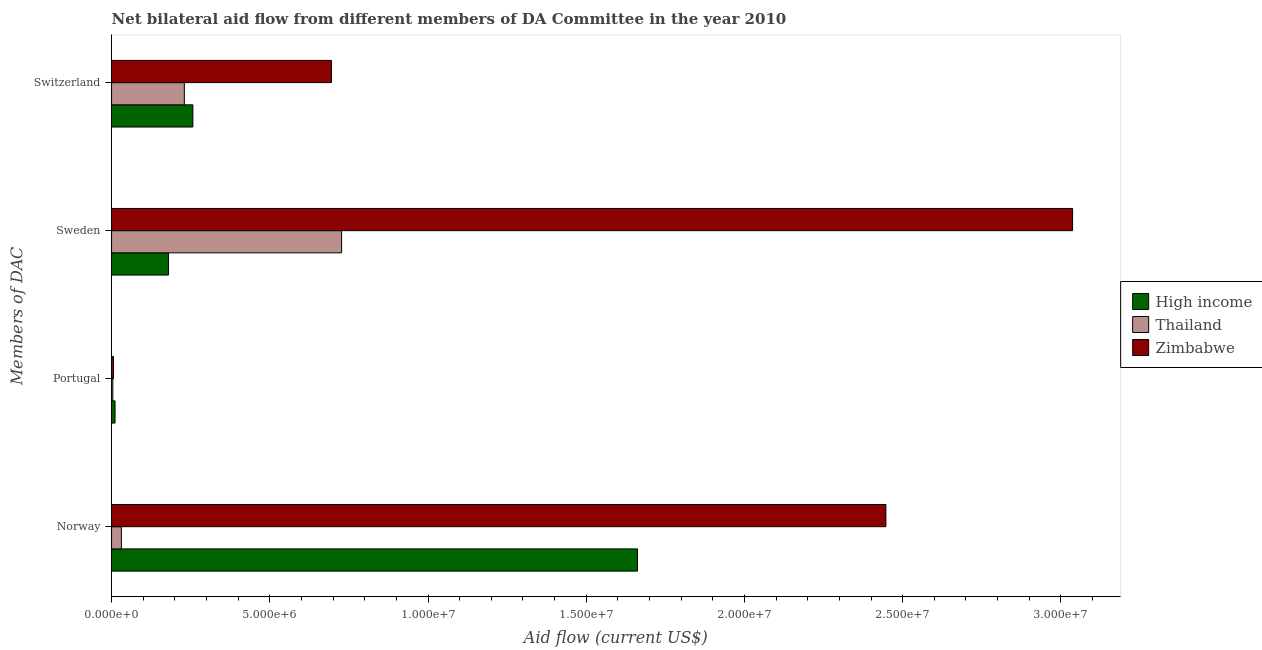How many groups of bars are there?
Ensure brevity in your answer.  4. Are the number of bars per tick equal to the number of legend labels?
Provide a short and direct response. Yes. How many bars are there on the 1st tick from the top?
Provide a short and direct response. 3. What is the label of the 3rd group of bars from the top?
Your answer should be very brief. Portugal. What is the amount of aid given by portugal in Zimbabwe?
Ensure brevity in your answer.  6.00e+04. Across all countries, what is the maximum amount of aid given by sweden?
Keep it short and to the point. 3.04e+07. Across all countries, what is the minimum amount of aid given by portugal?
Keep it short and to the point. 4.00e+04. In which country was the amount of aid given by norway minimum?
Your response must be concise. Thailand. What is the total amount of aid given by switzerland in the graph?
Your response must be concise. 1.18e+07. What is the difference between the amount of aid given by norway in Thailand and that in High income?
Offer a very short reply. -1.63e+07. What is the difference between the amount of aid given by sweden in High income and the amount of aid given by norway in Zimbabwe?
Keep it short and to the point. -2.27e+07. What is the average amount of aid given by portugal per country?
Provide a short and direct response. 7.00e+04. What is the difference between the amount of aid given by portugal and amount of aid given by sweden in High income?
Provide a succinct answer. -1.69e+06. What is the ratio of the amount of aid given by portugal in Zimbabwe to that in High income?
Your answer should be very brief. 0.55. What is the difference between the highest and the second highest amount of aid given by portugal?
Offer a terse response. 5.00e+04. What is the difference between the highest and the lowest amount of aid given by switzerland?
Offer a very short reply. 4.65e+06. Is the sum of the amount of aid given by portugal in Thailand and Zimbabwe greater than the maximum amount of aid given by sweden across all countries?
Offer a very short reply. No. Is it the case that in every country, the sum of the amount of aid given by portugal and amount of aid given by switzerland is greater than the sum of amount of aid given by norway and amount of aid given by sweden?
Your answer should be compact. Yes. What does the 3rd bar from the bottom in Switzerland represents?
Offer a terse response. Zimbabwe. Are all the bars in the graph horizontal?
Your answer should be very brief. Yes. How many countries are there in the graph?
Your response must be concise. 3. Are the values on the major ticks of X-axis written in scientific E-notation?
Make the answer very short. Yes. Where does the legend appear in the graph?
Keep it short and to the point. Center right. What is the title of the graph?
Offer a terse response. Net bilateral aid flow from different members of DA Committee in the year 2010. What is the label or title of the Y-axis?
Your answer should be very brief. Members of DAC. What is the Aid flow (current US$) of High income in Norway?
Give a very brief answer. 1.66e+07. What is the Aid flow (current US$) in Zimbabwe in Norway?
Your answer should be very brief. 2.45e+07. What is the Aid flow (current US$) in High income in Portugal?
Provide a short and direct response. 1.10e+05. What is the Aid flow (current US$) of Thailand in Portugal?
Ensure brevity in your answer.  4.00e+04. What is the Aid flow (current US$) of High income in Sweden?
Give a very brief answer. 1.80e+06. What is the Aid flow (current US$) of Thailand in Sweden?
Give a very brief answer. 7.27e+06. What is the Aid flow (current US$) of Zimbabwe in Sweden?
Offer a terse response. 3.04e+07. What is the Aid flow (current US$) of High income in Switzerland?
Make the answer very short. 2.57e+06. What is the Aid flow (current US$) of Thailand in Switzerland?
Make the answer very short. 2.30e+06. What is the Aid flow (current US$) in Zimbabwe in Switzerland?
Make the answer very short. 6.95e+06. Across all Members of DAC, what is the maximum Aid flow (current US$) of High income?
Your response must be concise. 1.66e+07. Across all Members of DAC, what is the maximum Aid flow (current US$) in Thailand?
Ensure brevity in your answer.  7.27e+06. Across all Members of DAC, what is the maximum Aid flow (current US$) of Zimbabwe?
Provide a succinct answer. 3.04e+07. What is the total Aid flow (current US$) of High income in the graph?
Offer a terse response. 2.11e+07. What is the total Aid flow (current US$) in Thailand in the graph?
Provide a short and direct response. 9.92e+06. What is the total Aid flow (current US$) of Zimbabwe in the graph?
Provide a short and direct response. 6.18e+07. What is the difference between the Aid flow (current US$) of High income in Norway and that in Portugal?
Provide a succinct answer. 1.65e+07. What is the difference between the Aid flow (current US$) in Thailand in Norway and that in Portugal?
Your response must be concise. 2.70e+05. What is the difference between the Aid flow (current US$) in Zimbabwe in Norway and that in Portugal?
Provide a succinct answer. 2.44e+07. What is the difference between the Aid flow (current US$) in High income in Norway and that in Sweden?
Offer a very short reply. 1.48e+07. What is the difference between the Aid flow (current US$) of Thailand in Norway and that in Sweden?
Provide a succinct answer. -6.96e+06. What is the difference between the Aid flow (current US$) of Zimbabwe in Norway and that in Sweden?
Offer a very short reply. -5.90e+06. What is the difference between the Aid flow (current US$) of High income in Norway and that in Switzerland?
Ensure brevity in your answer.  1.40e+07. What is the difference between the Aid flow (current US$) of Thailand in Norway and that in Switzerland?
Your response must be concise. -1.99e+06. What is the difference between the Aid flow (current US$) in Zimbabwe in Norway and that in Switzerland?
Your response must be concise. 1.75e+07. What is the difference between the Aid flow (current US$) of High income in Portugal and that in Sweden?
Keep it short and to the point. -1.69e+06. What is the difference between the Aid flow (current US$) of Thailand in Portugal and that in Sweden?
Offer a terse response. -7.23e+06. What is the difference between the Aid flow (current US$) of Zimbabwe in Portugal and that in Sweden?
Provide a succinct answer. -3.03e+07. What is the difference between the Aid flow (current US$) of High income in Portugal and that in Switzerland?
Keep it short and to the point. -2.46e+06. What is the difference between the Aid flow (current US$) of Thailand in Portugal and that in Switzerland?
Your response must be concise. -2.26e+06. What is the difference between the Aid flow (current US$) of Zimbabwe in Portugal and that in Switzerland?
Your answer should be very brief. -6.89e+06. What is the difference between the Aid flow (current US$) of High income in Sweden and that in Switzerland?
Your response must be concise. -7.70e+05. What is the difference between the Aid flow (current US$) of Thailand in Sweden and that in Switzerland?
Offer a terse response. 4.97e+06. What is the difference between the Aid flow (current US$) of Zimbabwe in Sweden and that in Switzerland?
Your answer should be compact. 2.34e+07. What is the difference between the Aid flow (current US$) of High income in Norway and the Aid flow (current US$) of Thailand in Portugal?
Provide a short and direct response. 1.66e+07. What is the difference between the Aid flow (current US$) in High income in Norway and the Aid flow (current US$) in Zimbabwe in Portugal?
Make the answer very short. 1.66e+07. What is the difference between the Aid flow (current US$) in High income in Norway and the Aid flow (current US$) in Thailand in Sweden?
Keep it short and to the point. 9.35e+06. What is the difference between the Aid flow (current US$) of High income in Norway and the Aid flow (current US$) of Zimbabwe in Sweden?
Give a very brief answer. -1.38e+07. What is the difference between the Aid flow (current US$) of Thailand in Norway and the Aid flow (current US$) of Zimbabwe in Sweden?
Ensure brevity in your answer.  -3.01e+07. What is the difference between the Aid flow (current US$) of High income in Norway and the Aid flow (current US$) of Thailand in Switzerland?
Provide a succinct answer. 1.43e+07. What is the difference between the Aid flow (current US$) in High income in Norway and the Aid flow (current US$) in Zimbabwe in Switzerland?
Provide a short and direct response. 9.67e+06. What is the difference between the Aid flow (current US$) of Thailand in Norway and the Aid flow (current US$) of Zimbabwe in Switzerland?
Offer a very short reply. -6.64e+06. What is the difference between the Aid flow (current US$) in High income in Portugal and the Aid flow (current US$) in Thailand in Sweden?
Offer a terse response. -7.16e+06. What is the difference between the Aid flow (current US$) of High income in Portugal and the Aid flow (current US$) of Zimbabwe in Sweden?
Your answer should be compact. -3.03e+07. What is the difference between the Aid flow (current US$) of Thailand in Portugal and the Aid flow (current US$) of Zimbabwe in Sweden?
Ensure brevity in your answer.  -3.03e+07. What is the difference between the Aid flow (current US$) in High income in Portugal and the Aid flow (current US$) in Thailand in Switzerland?
Give a very brief answer. -2.19e+06. What is the difference between the Aid flow (current US$) of High income in Portugal and the Aid flow (current US$) of Zimbabwe in Switzerland?
Keep it short and to the point. -6.84e+06. What is the difference between the Aid flow (current US$) of Thailand in Portugal and the Aid flow (current US$) of Zimbabwe in Switzerland?
Provide a short and direct response. -6.91e+06. What is the difference between the Aid flow (current US$) of High income in Sweden and the Aid flow (current US$) of Thailand in Switzerland?
Provide a short and direct response. -5.00e+05. What is the difference between the Aid flow (current US$) in High income in Sweden and the Aid flow (current US$) in Zimbabwe in Switzerland?
Offer a very short reply. -5.15e+06. What is the average Aid flow (current US$) in High income per Members of DAC?
Offer a very short reply. 5.28e+06. What is the average Aid flow (current US$) of Thailand per Members of DAC?
Provide a succinct answer. 2.48e+06. What is the average Aid flow (current US$) in Zimbabwe per Members of DAC?
Give a very brief answer. 1.55e+07. What is the difference between the Aid flow (current US$) in High income and Aid flow (current US$) in Thailand in Norway?
Provide a short and direct response. 1.63e+07. What is the difference between the Aid flow (current US$) of High income and Aid flow (current US$) of Zimbabwe in Norway?
Ensure brevity in your answer.  -7.85e+06. What is the difference between the Aid flow (current US$) in Thailand and Aid flow (current US$) in Zimbabwe in Norway?
Keep it short and to the point. -2.42e+07. What is the difference between the Aid flow (current US$) in High income and Aid flow (current US$) in Thailand in Portugal?
Ensure brevity in your answer.  7.00e+04. What is the difference between the Aid flow (current US$) of High income and Aid flow (current US$) of Zimbabwe in Portugal?
Ensure brevity in your answer.  5.00e+04. What is the difference between the Aid flow (current US$) in Thailand and Aid flow (current US$) in Zimbabwe in Portugal?
Keep it short and to the point. -2.00e+04. What is the difference between the Aid flow (current US$) in High income and Aid flow (current US$) in Thailand in Sweden?
Ensure brevity in your answer.  -5.47e+06. What is the difference between the Aid flow (current US$) in High income and Aid flow (current US$) in Zimbabwe in Sweden?
Provide a succinct answer. -2.86e+07. What is the difference between the Aid flow (current US$) in Thailand and Aid flow (current US$) in Zimbabwe in Sweden?
Give a very brief answer. -2.31e+07. What is the difference between the Aid flow (current US$) in High income and Aid flow (current US$) in Zimbabwe in Switzerland?
Provide a short and direct response. -4.38e+06. What is the difference between the Aid flow (current US$) in Thailand and Aid flow (current US$) in Zimbabwe in Switzerland?
Ensure brevity in your answer.  -4.65e+06. What is the ratio of the Aid flow (current US$) of High income in Norway to that in Portugal?
Ensure brevity in your answer.  151.09. What is the ratio of the Aid flow (current US$) in Thailand in Norway to that in Portugal?
Provide a succinct answer. 7.75. What is the ratio of the Aid flow (current US$) in Zimbabwe in Norway to that in Portugal?
Provide a succinct answer. 407.83. What is the ratio of the Aid flow (current US$) of High income in Norway to that in Sweden?
Keep it short and to the point. 9.23. What is the ratio of the Aid flow (current US$) of Thailand in Norway to that in Sweden?
Your answer should be compact. 0.04. What is the ratio of the Aid flow (current US$) in Zimbabwe in Norway to that in Sweden?
Provide a succinct answer. 0.81. What is the ratio of the Aid flow (current US$) in High income in Norway to that in Switzerland?
Your response must be concise. 6.47. What is the ratio of the Aid flow (current US$) in Thailand in Norway to that in Switzerland?
Keep it short and to the point. 0.13. What is the ratio of the Aid flow (current US$) of Zimbabwe in Norway to that in Switzerland?
Provide a succinct answer. 3.52. What is the ratio of the Aid flow (current US$) of High income in Portugal to that in Sweden?
Your answer should be very brief. 0.06. What is the ratio of the Aid flow (current US$) in Thailand in Portugal to that in Sweden?
Offer a very short reply. 0.01. What is the ratio of the Aid flow (current US$) in Zimbabwe in Portugal to that in Sweden?
Offer a terse response. 0. What is the ratio of the Aid flow (current US$) in High income in Portugal to that in Switzerland?
Give a very brief answer. 0.04. What is the ratio of the Aid flow (current US$) of Thailand in Portugal to that in Switzerland?
Your answer should be compact. 0.02. What is the ratio of the Aid flow (current US$) of Zimbabwe in Portugal to that in Switzerland?
Offer a terse response. 0.01. What is the ratio of the Aid flow (current US$) in High income in Sweden to that in Switzerland?
Offer a terse response. 0.7. What is the ratio of the Aid flow (current US$) of Thailand in Sweden to that in Switzerland?
Your answer should be compact. 3.16. What is the ratio of the Aid flow (current US$) of Zimbabwe in Sweden to that in Switzerland?
Offer a very short reply. 4.37. What is the difference between the highest and the second highest Aid flow (current US$) in High income?
Offer a terse response. 1.40e+07. What is the difference between the highest and the second highest Aid flow (current US$) in Thailand?
Give a very brief answer. 4.97e+06. What is the difference between the highest and the second highest Aid flow (current US$) in Zimbabwe?
Make the answer very short. 5.90e+06. What is the difference between the highest and the lowest Aid flow (current US$) of High income?
Your answer should be very brief. 1.65e+07. What is the difference between the highest and the lowest Aid flow (current US$) of Thailand?
Keep it short and to the point. 7.23e+06. What is the difference between the highest and the lowest Aid flow (current US$) in Zimbabwe?
Your answer should be very brief. 3.03e+07. 